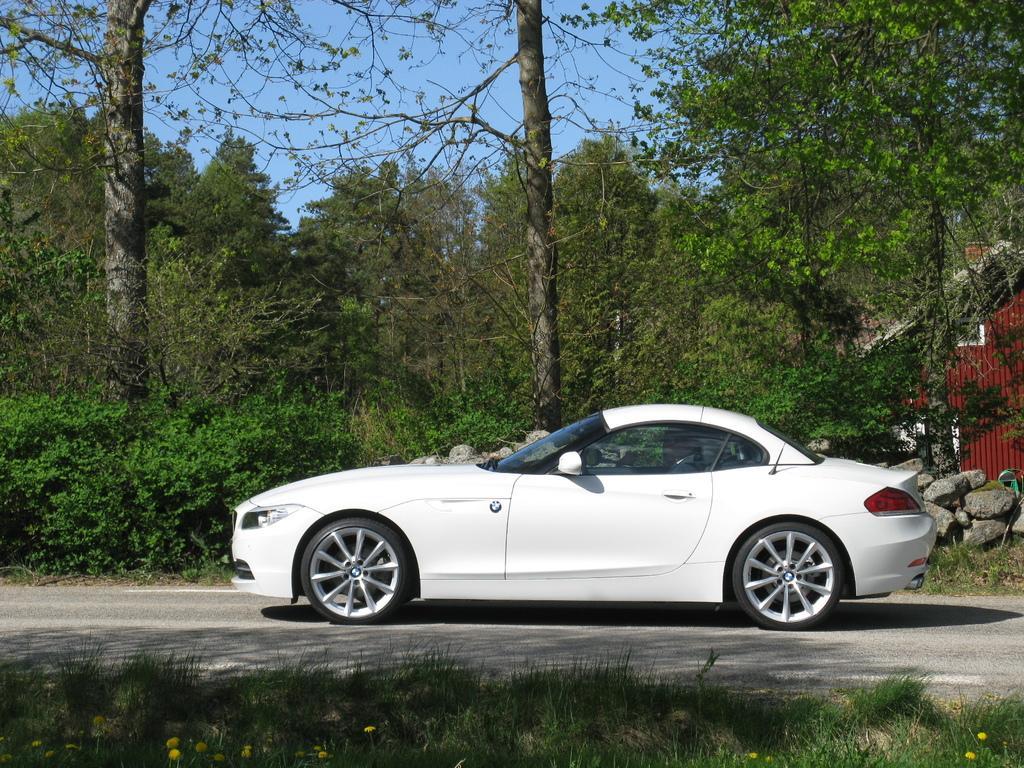How would you summarize this image in a sentence or two? In this image we can see white color car on the land. Bottom of the image grassy land is there. Behind the car trees are there. Right side of the image one house is there. At the top of the image sky is present. 